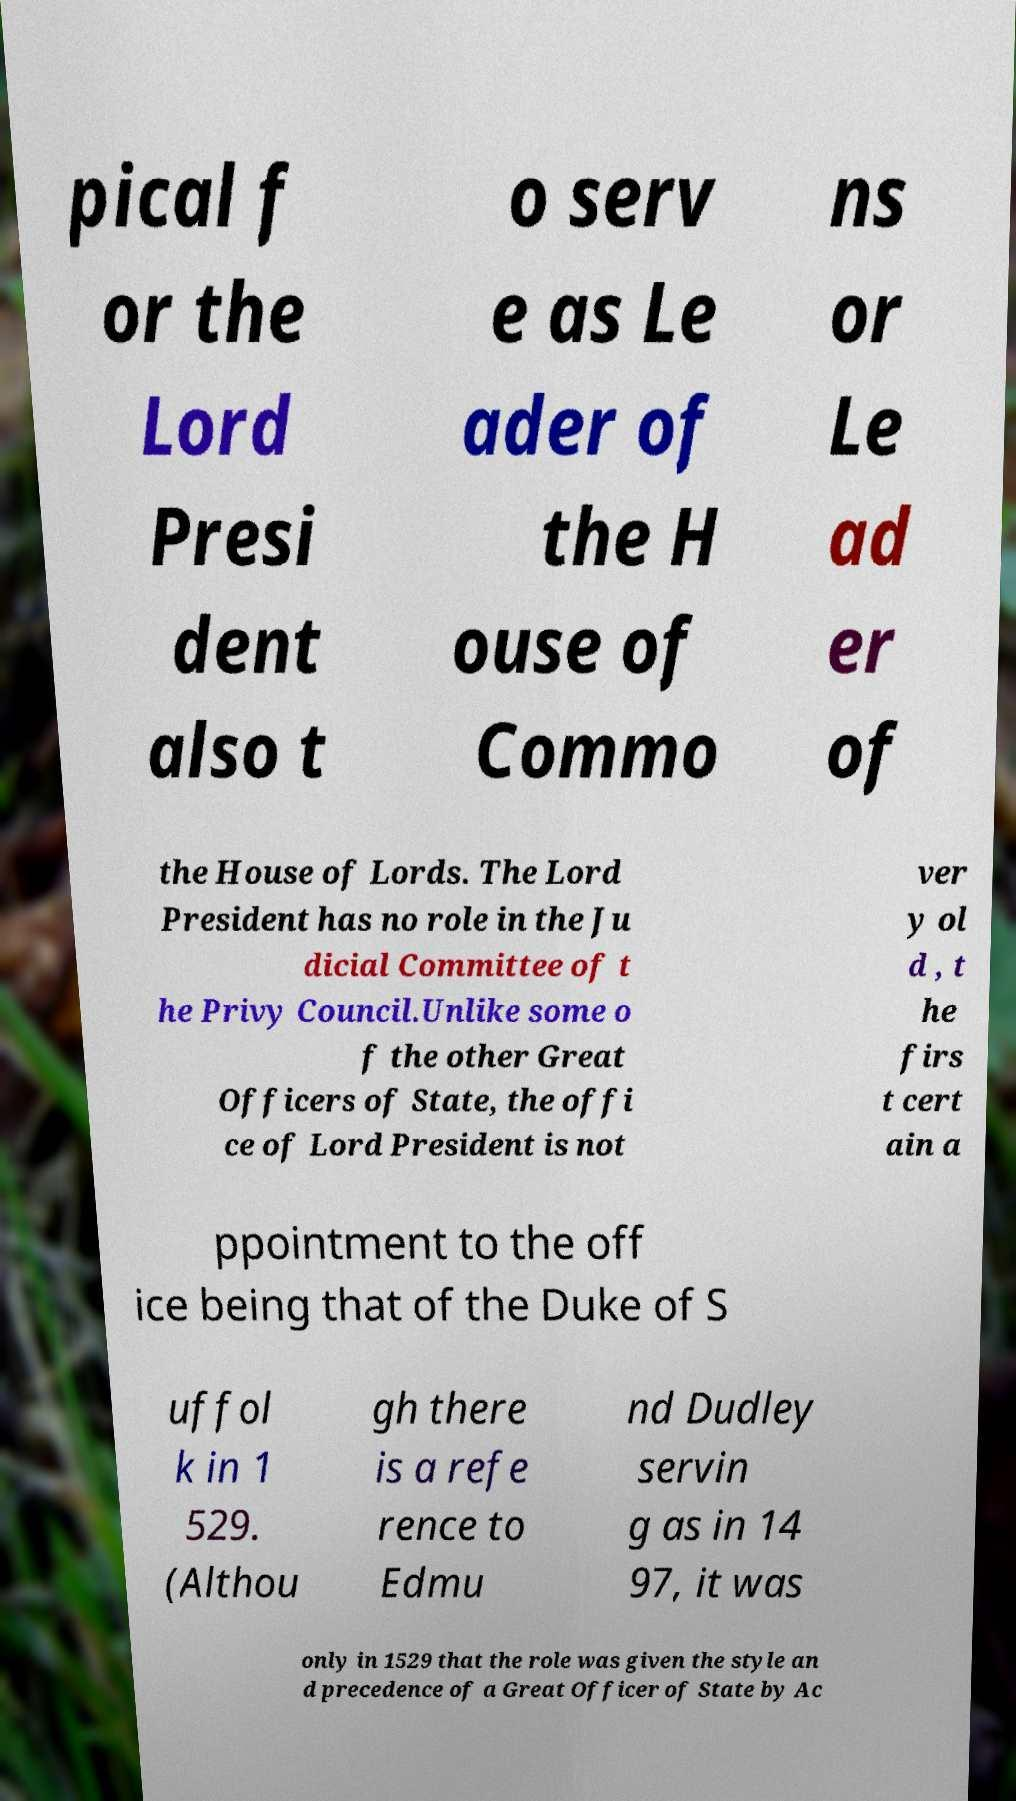Can you accurately transcribe the text from the provided image for me? pical f or the Lord Presi dent also t o serv e as Le ader of the H ouse of Commo ns or Le ad er of the House of Lords. The Lord President has no role in the Ju dicial Committee of t he Privy Council.Unlike some o f the other Great Officers of State, the offi ce of Lord President is not ver y ol d , t he firs t cert ain a ppointment to the off ice being that of the Duke of S uffol k in 1 529. (Althou gh there is a refe rence to Edmu nd Dudley servin g as in 14 97, it was only in 1529 that the role was given the style an d precedence of a Great Officer of State by Ac 